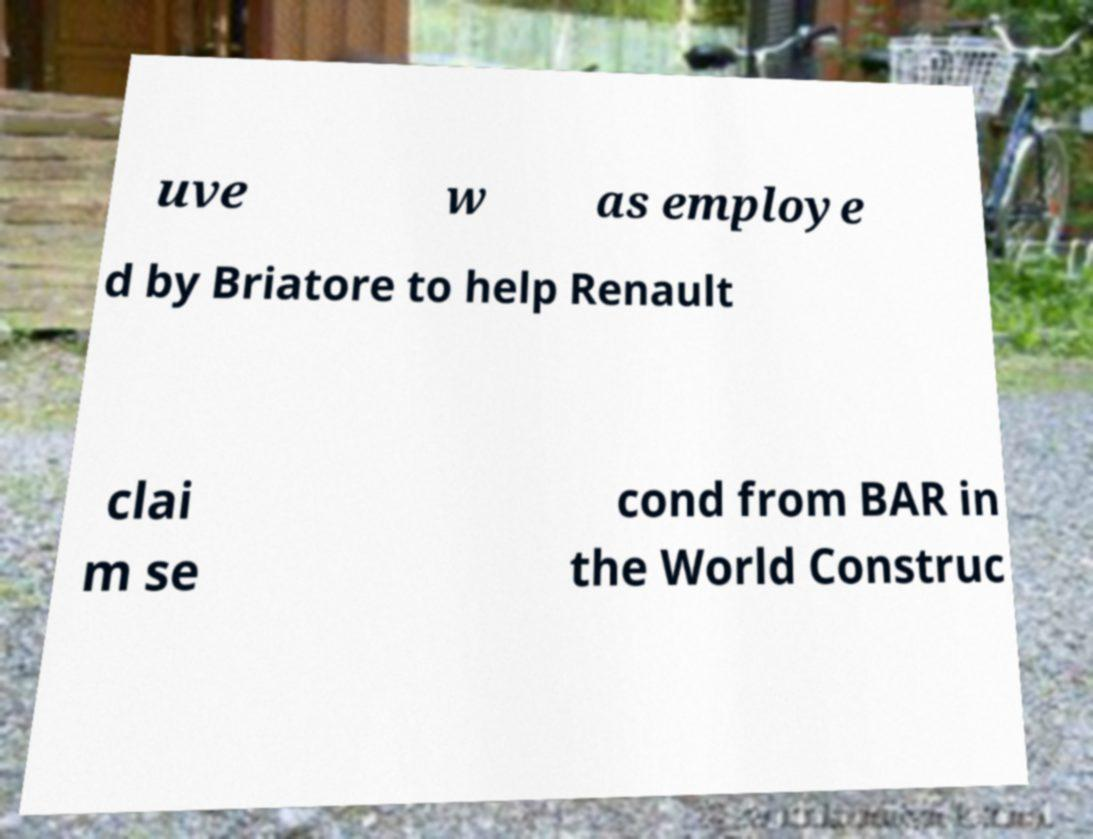I need the written content from this picture converted into text. Can you do that? uve w as employe d by Briatore to help Renault clai m se cond from BAR in the World Construc 